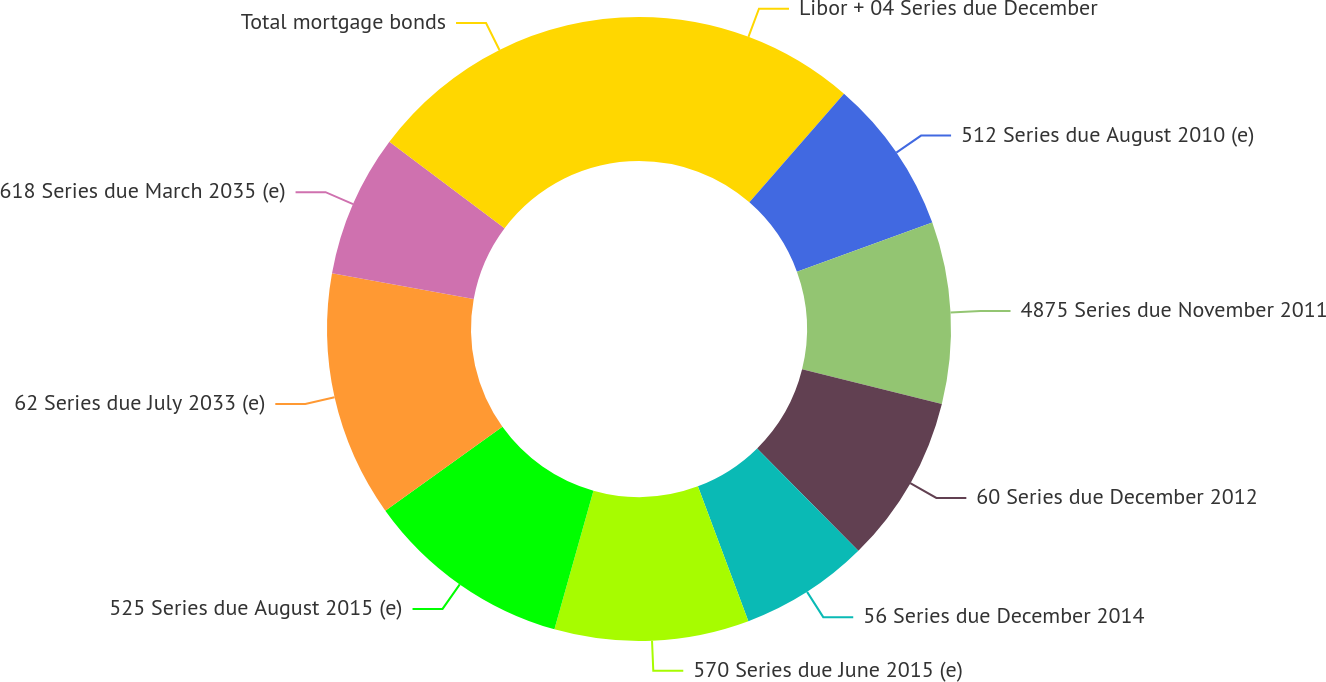<chart> <loc_0><loc_0><loc_500><loc_500><pie_chart><fcel>Libor + 04 Series due December<fcel>512 Series due August 2010 (e)<fcel>4875 Series due November 2011<fcel>60 Series due December 2012<fcel>56 Series due December 2014<fcel>570 Series due June 2015 (e)<fcel>525 Series due August 2015 (e)<fcel>62 Series due July 2033 (e)<fcel>618 Series due March 2035 (e)<fcel>Total mortgage bonds<nl><fcel>11.41%<fcel>8.05%<fcel>9.4%<fcel>8.73%<fcel>6.71%<fcel>10.07%<fcel>10.74%<fcel>12.75%<fcel>7.38%<fcel>14.76%<nl></chart> 